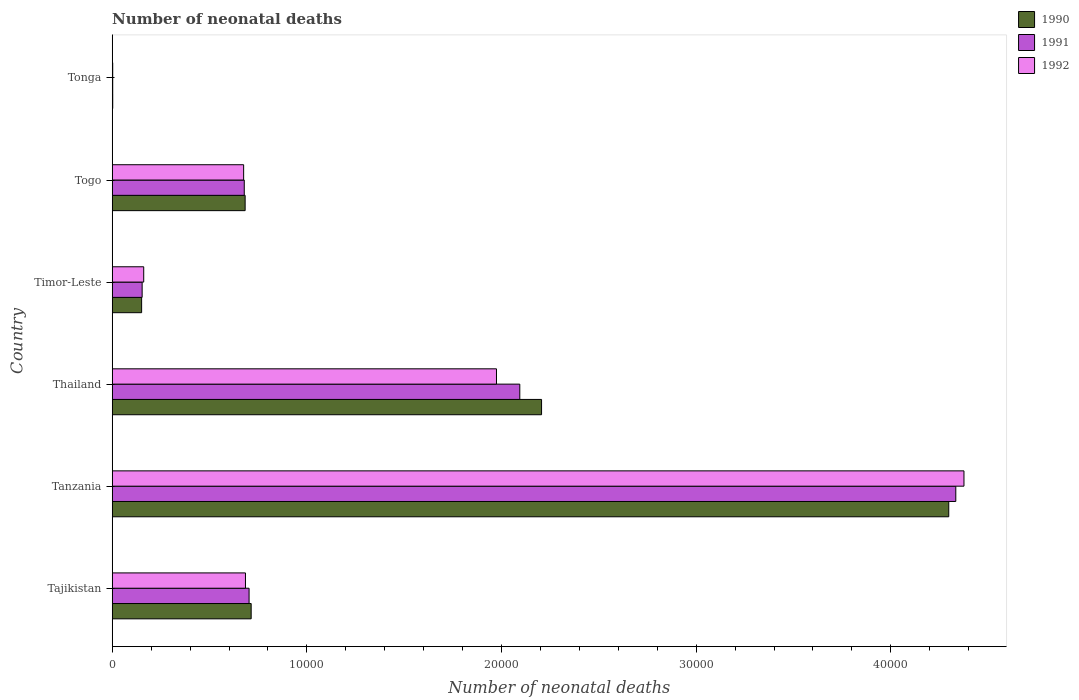Are the number of bars per tick equal to the number of legend labels?
Provide a succinct answer. Yes. Are the number of bars on each tick of the Y-axis equal?
Make the answer very short. Yes. How many bars are there on the 5th tick from the bottom?
Give a very brief answer. 3. What is the label of the 3rd group of bars from the top?
Give a very brief answer. Timor-Leste. What is the number of neonatal deaths in in 1991 in Tajikistan?
Your answer should be very brief. 7031. Across all countries, what is the maximum number of neonatal deaths in in 1992?
Offer a very short reply. 4.38e+04. Across all countries, what is the minimum number of neonatal deaths in in 1992?
Ensure brevity in your answer.  25. In which country was the number of neonatal deaths in in 1992 maximum?
Give a very brief answer. Tanzania. In which country was the number of neonatal deaths in in 1990 minimum?
Keep it short and to the point. Tonga. What is the total number of neonatal deaths in in 1992 in the graph?
Your answer should be compact. 7.87e+04. What is the difference between the number of neonatal deaths in in 1991 in Tanzania and that in Timor-Leste?
Provide a short and direct response. 4.18e+04. What is the difference between the number of neonatal deaths in in 1992 in Tonga and the number of neonatal deaths in in 1990 in Togo?
Your answer should be compact. -6803. What is the average number of neonatal deaths in in 1990 per country?
Offer a terse response. 1.34e+04. What is the difference between the number of neonatal deaths in in 1990 and number of neonatal deaths in in 1991 in Tanzania?
Offer a very short reply. -362. In how many countries, is the number of neonatal deaths in in 1990 greater than 38000 ?
Keep it short and to the point. 1. What is the ratio of the number of neonatal deaths in in 1990 in Tanzania to that in Togo?
Ensure brevity in your answer.  6.29. Is the number of neonatal deaths in in 1992 in Timor-Leste less than that in Togo?
Your response must be concise. Yes. Is the difference between the number of neonatal deaths in in 1990 in Tanzania and Tonga greater than the difference between the number of neonatal deaths in in 1991 in Tanzania and Tonga?
Provide a short and direct response. No. What is the difference between the highest and the second highest number of neonatal deaths in in 1992?
Your answer should be compact. 2.40e+04. What is the difference between the highest and the lowest number of neonatal deaths in in 1992?
Provide a succinct answer. 4.37e+04. In how many countries, is the number of neonatal deaths in in 1992 greater than the average number of neonatal deaths in in 1992 taken over all countries?
Offer a very short reply. 2. Is the sum of the number of neonatal deaths in in 1990 in Tajikistan and Tanzania greater than the maximum number of neonatal deaths in in 1992 across all countries?
Provide a short and direct response. Yes. What does the 2nd bar from the top in Tajikistan represents?
Ensure brevity in your answer.  1991. Is it the case that in every country, the sum of the number of neonatal deaths in in 1992 and number of neonatal deaths in in 1990 is greater than the number of neonatal deaths in in 1991?
Make the answer very short. Yes. How many bars are there?
Ensure brevity in your answer.  18. What is the difference between two consecutive major ticks on the X-axis?
Your answer should be very brief. 10000. Are the values on the major ticks of X-axis written in scientific E-notation?
Keep it short and to the point. No. Does the graph contain any zero values?
Offer a very short reply. No. Where does the legend appear in the graph?
Offer a very short reply. Top right. How are the legend labels stacked?
Provide a succinct answer. Vertical. What is the title of the graph?
Offer a terse response. Number of neonatal deaths. What is the label or title of the X-axis?
Ensure brevity in your answer.  Number of neonatal deaths. What is the Number of neonatal deaths in 1990 in Tajikistan?
Your answer should be very brief. 7138. What is the Number of neonatal deaths of 1991 in Tajikistan?
Your answer should be compact. 7031. What is the Number of neonatal deaths in 1992 in Tajikistan?
Offer a very short reply. 6845. What is the Number of neonatal deaths in 1990 in Tanzania?
Give a very brief answer. 4.30e+04. What is the Number of neonatal deaths in 1991 in Tanzania?
Provide a short and direct response. 4.33e+04. What is the Number of neonatal deaths in 1992 in Tanzania?
Keep it short and to the point. 4.38e+04. What is the Number of neonatal deaths in 1990 in Thailand?
Ensure brevity in your answer.  2.21e+04. What is the Number of neonatal deaths in 1991 in Thailand?
Make the answer very short. 2.09e+04. What is the Number of neonatal deaths in 1992 in Thailand?
Make the answer very short. 1.97e+04. What is the Number of neonatal deaths of 1990 in Timor-Leste?
Give a very brief answer. 1510. What is the Number of neonatal deaths in 1991 in Timor-Leste?
Keep it short and to the point. 1537. What is the Number of neonatal deaths of 1992 in Timor-Leste?
Provide a succinct answer. 1618. What is the Number of neonatal deaths of 1990 in Togo?
Offer a very short reply. 6828. What is the Number of neonatal deaths in 1991 in Togo?
Your answer should be very brief. 6783. What is the Number of neonatal deaths of 1992 in Togo?
Give a very brief answer. 6751. What is the Number of neonatal deaths in 1991 in Tonga?
Provide a short and direct response. 25. Across all countries, what is the maximum Number of neonatal deaths of 1990?
Your answer should be very brief. 4.30e+04. Across all countries, what is the maximum Number of neonatal deaths in 1991?
Make the answer very short. 4.33e+04. Across all countries, what is the maximum Number of neonatal deaths of 1992?
Offer a terse response. 4.38e+04. Across all countries, what is the minimum Number of neonatal deaths in 1990?
Provide a short and direct response. 26. Across all countries, what is the minimum Number of neonatal deaths of 1991?
Ensure brevity in your answer.  25. Across all countries, what is the minimum Number of neonatal deaths in 1992?
Your answer should be compact. 25. What is the total Number of neonatal deaths of 1990 in the graph?
Your answer should be very brief. 8.05e+04. What is the total Number of neonatal deaths in 1991 in the graph?
Offer a very short reply. 7.97e+04. What is the total Number of neonatal deaths of 1992 in the graph?
Provide a short and direct response. 7.87e+04. What is the difference between the Number of neonatal deaths of 1990 in Tajikistan and that in Tanzania?
Provide a short and direct response. -3.58e+04. What is the difference between the Number of neonatal deaths in 1991 in Tajikistan and that in Tanzania?
Provide a succinct answer. -3.63e+04. What is the difference between the Number of neonatal deaths of 1992 in Tajikistan and that in Tanzania?
Offer a terse response. -3.69e+04. What is the difference between the Number of neonatal deaths in 1990 in Tajikistan and that in Thailand?
Your answer should be very brief. -1.49e+04. What is the difference between the Number of neonatal deaths of 1991 in Tajikistan and that in Thailand?
Your answer should be compact. -1.39e+04. What is the difference between the Number of neonatal deaths of 1992 in Tajikistan and that in Thailand?
Keep it short and to the point. -1.29e+04. What is the difference between the Number of neonatal deaths in 1990 in Tajikistan and that in Timor-Leste?
Your answer should be compact. 5628. What is the difference between the Number of neonatal deaths in 1991 in Tajikistan and that in Timor-Leste?
Give a very brief answer. 5494. What is the difference between the Number of neonatal deaths in 1992 in Tajikistan and that in Timor-Leste?
Give a very brief answer. 5227. What is the difference between the Number of neonatal deaths in 1990 in Tajikistan and that in Togo?
Provide a short and direct response. 310. What is the difference between the Number of neonatal deaths in 1991 in Tajikistan and that in Togo?
Your response must be concise. 248. What is the difference between the Number of neonatal deaths of 1992 in Tajikistan and that in Togo?
Give a very brief answer. 94. What is the difference between the Number of neonatal deaths of 1990 in Tajikistan and that in Tonga?
Provide a short and direct response. 7112. What is the difference between the Number of neonatal deaths of 1991 in Tajikistan and that in Tonga?
Offer a terse response. 7006. What is the difference between the Number of neonatal deaths of 1992 in Tajikistan and that in Tonga?
Give a very brief answer. 6820. What is the difference between the Number of neonatal deaths in 1990 in Tanzania and that in Thailand?
Keep it short and to the point. 2.09e+04. What is the difference between the Number of neonatal deaths in 1991 in Tanzania and that in Thailand?
Your response must be concise. 2.24e+04. What is the difference between the Number of neonatal deaths in 1992 in Tanzania and that in Thailand?
Provide a succinct answer. 2.40e+04. What is the difference between the Number of neonatal deaths in 1990 in Tanzania and that in Timor-Leste?
Provide a succinct answer. 4.15e+04. What is the difference between the Number of neonatal deaths in 1991 in Tanzania and that in Timor-Leste?
Your response must be concise. 4.18e+04. What is the difference between the Number of neonatal deaths in 1992 in Tanzania and that in Timor-Leste?
Ensure brevity in your answer.  4.21e+04. What is the difference between the Number of neonatal deaths of 1990 in Tanzania and that in Togo?
Your answer should be very brief. 3.61e+04. What is the difference between the Number of neonatal deaths of 1991 in Tanzania and that in Togo?
Ensure brevity in your answer.  3.66e+04. What is the difference between the Number of neonatal deaths of 1992 in Tanzania and that in Togo?
Keep it short and to the point. 3.70e+04. What is the difference between the Number of neonatal deaths of 1990 in Tanzania and that in Tonga?
Your answer should be compact. 4.30e+04. What is the difference between the Number of neonatal deaths of 1991 in Tanzania and that in Tonga?
Keep it short and to the point. 4.33e+04. What is the difference between the Number of neonatal deaths in 1992 in Tanzania and that in Tonga?
Offer a very short reply. 4.37e+04. What is the difference between the Number of neonatal deaths of 1990 in Thailand and that in Timor-Leste?
Make the answer very short. 2.05e+04. What is the difference between the Number of neonatal deaths in 1991 in Thailand and that in Timor-Leste?
Provide a short and direct response. 1.94e+04. What is the difference between the Number of neonatal deaths in 1992 in Thailand and that in Timor-Leste?
Your response must be concise. 1.81e+04. What is the difference between the Number of neonatal deaths in 1990 in Thailand and that in Togo?
Give a very brief answer. 1.52e+04. What is the difference between the Number of neonatal deaths in 1991 in Thailand and that in Togo?
Make the answer very short. 1.42e+04. What is the difference between the Number of neonatal deaths of 1992 in Thailand and that in Togo?
Your answer should be very brief. 1.30e+04. What is the difference between the Number of neonatal deaths in 1990 in Thailand and that in Tonga?
Make the answer very short. 2.20e+04. What is the difference between the Number of neonatal deaths of 1991 in Thailand and that in Tonga?
Give a very brief answer. 2.09e+04. What is the difference between the Number of neonatal deaths of 1992 in Thailand and that in Tonga?
Make the answer very short. 1.97e+04. What is the difference between the Number of neonatal deaths in 1990 in Timor-Leste and that in Togo?
Give a very brief answer. -5318. What is the difference between the Number of neonatal deaths of 1991 in Timor-Leste and that in Togo?
Offer a terse response. -5246. What is the difference between the Number of neonatal deaths of 1992 in Timor-Leste and that in Togo?
Provide a succinct answer. -5133. What is the difference between the Number of neonatal deaths in 1990 in Timor-Leste and that in Tonga?
Provide a succinct answer. 1484. What is the difference between the Number of neonatal deaths in 1991 in Timor-Leste and that in Tonga?
Offer a very short reply. 1512. What is the difference between the Number of neonatal deaths in 1992 in Timor-Leste and that in Tonga?
Offer a very short reply. 1593. What is the difference between the Number of neonatal deaths of 1990 in Togo and that in Tonga?
Your answer should be compact. 6802. What is the difference between the Number of neonatal deaths in 1991 in Togo and that in Tonga?
Your response must be concise. 6758. What is the difference between the Number of neonatal deaths of 1992 in Togo and that in Tonga?
Your answer should be compact. 6726. What is the difference between the Number of neonatal deaths in 1990 in Tajikistan and the Number of neonatal deaths in 1991 in Tanzania?
Your response must be concise. -3.62e+04. What is the difference between the Number of neonatal deaths of 1990 in Tajikistan and the Number of neonatal deaths of 1992 in Tanzania?
Offer a very short reply. -3.66e+04. What is the difference between the Number of neonatal deaths in 1991 in Tajikistan and the Number of neonatal deaths in 1992 in Tanzania?
Ensure brevity in your answer.  -3.67e+04. What is the difference between the Number of neonatal deaths in 1990 in Tajikistan and the Number of neonatal deaths in 1991 in Thailand?
Provide a succinct answer. -1.38e+04. What is the difference between the Number of neonatal deaths of 1990 in Tajikistan and the Number of neonatal deaths of 1992 in Thailand?
Ensure brevity in your answer.  -1.26e+04. What is the difference between the Number of neonatal deaths in 1991 in Tajikistan and the Number of neonatal deaths in 1992 in Thailand?
Offer a very short reply. -1.27e+04. What is the difference between the Number of neonatal deaths in 1990 in Tajikistan and the Number of neonatal deaths in 1991 in Timor-Leste?
Provide a short and direct response. 5601. What is the difference between the Number of neonatal deaths in 1990 in Tajikistan and the Number of neonatal deaths in 1992 in Timor-Leste?
Offer a terse response. 5520. What is the difference between the Number of neonatal deaths of 1991 in Tajikistan and the Number of neonatal deaths of 1992 in Timor-Leste?
Your answer should be very brief. 5413. What is the difference between the Number of neonatal deaths of 1990 in Tajikistan and the Number of neonatal deaths of 1991 in Togo?
Make the answer very short. 355. What is the difference between the Number of neonatal deaths of 1990 in Tajikistan and the Number of neonatal deaths of 1992 in Togo?
Ensure brevity in your answer.  387. What is the difference between the Number of neonatal deaths of 1991 in Tajikistan and the Number of neonatal deaths of 1992 in Togo?
Your answer should be very brief. 280. What is the difference between the Number of neonatal deaths in 1990 in Tajikistan and the Number of neonatal deaths in 1991 in Tonga?
Your answer should be very brief. 7113. What is the difference between the Number of neonatal deaths of 1990 in Tajikistan and the Number of neonatal deaths of 1992 in Tonga?
Offer a very short reply. 7113. What is the difference between the Number of neonatal deaths in 1991 in Tajikistan and the Number of neonatal deaths in 1992 in Tonga?
Give a very brief answer. 7006. What is the difference between the Number of neonatal deaths of 1990 in Tanzania and the Number of neonatal deaths of 1991 in Thailand?
Your answer should be compact. 2.20e+04. What is the difference between the Number of neonatal deaths in 1990 in Tanzania and the Number of neonatal deaths in 1992 in Thailand?
Your answer should be very brief. 2.32e+04. What is the difference between the Number of neonatal deaths of 1991 in Tanzania and the Number of neonatal deaths of 1992 in Thailand?
Ensure brevity in your answer.  2.36e+04. What is the difference between the Number of neonatal deaths in 1990 in Tanzania and the Number of neonatal deaths in 1991 in Timor-Leste?
Keep it short and to the point. 4.14e+04. What is the difference between the Number of neonatal deaths in 1990 in Tanzania and the Number of neonatal deaths in 1992 in Timor-Leste?
Keep it short and to the point. 4.14e+04. What is the difference between the Number of neonatal deaths in 1991 in Tanzania and the Number of neonatal deaths in 1992 in Timor-Leste?
Keep it short and to the point. 4.17e+04. What is the difference between the Number of neonatal deaths in 1990 in Tanzania and the Number of neonatal deaths in 1991 in Togo?
Keep it short and to the point. 3.62e+04. What is the difference between the Number of neonatal deaths in 1990 in Tanzania and the Number of neonatal deaths in 1992 in Togo?
Offer a terse response. 3.62e+04. What is the difference between the Number of neonatal deaths of 1991 in Tanzania and the Number of neonatal deaths of 1992 in Togo?
Give a very brief answer. 3.66e+04. What is the difference between the Number of neonatal deaths of 1990 in Tanzania and the Number of neonatal deaths of 1991 in Tonga?
Offer a very short reply. 4.30e+04. What is the difference between the Number of neonatal deaths of 1990 in Tanzania and the Number of neonatal deaths of 1992 in Tonga?
Provide a succinct answer. 4.30e+04. What is the difference between the Number of neonatal deaths in 1991 in Tanzania and the Number of neonatal deaths in 1992 in Tonga?
Offer a very short reply. 4.33e+04. What is the difference between the Number of neonatal deaths in 1990 in Thailand and the Number of neonatal deaths in 1991 in Timor-Leste?
Offer a terse response. 2.05e+04. What is the difference between the Number of neonatal deaths of 1990 in Thailand and the Number of neonatal deaths of 1992 in Timor-Leste?
Give a very brief answer. 2.04e+04. What is the difference between the Number of neonatal deaths in 1991 in Thailand and the Number of neonatal deaths in 1992 in Timor-Leste?
Make the answer very short. 1.93e+04. What is the difference between the Number of neonatal deaths in 1990 in Thailand and the Number of neonatal deaths in 1991 in Togo?
Provide a succinct answer. 1.53e+04. What is the difference between the Number of neonatal deaths in 1990 in Thailand and the Number of neonatal deaths in 1992 in Togo?
Give a very brief answer. 1.53e+04. What is the difference between the Number of neonatal deaths of 1991 in Thailand and the Number of neonatal deaths of 1992 in Togo?
Provide a short and direct response. 1.42e+04. What is the difference between the Number of neonatal deaths of 1990 in Thailand and the Number of neonatal deaths of 1991 in Tonga?
Make the answer very short. 2.20e+04. What is the difference between the Number of neonatal deaths of 1990 in Thailand and the Number of neonatal deaths of 1992 in Tonga?
Your answer should be compact. 2.20e+04. What is the difference between the Number of neonatal deaths of 1991 in Thailand and the Number of neonatal deaths of 1992 in Tonga?
Provide a succinct answer. 2.09e+04. What is the difference between the Number of neonatal deaths in 1990 in Timor-Leste and the Number of neonatal deaths in 1991 in Togo?
Provide a short and direct response. -5273. What is the difference between the Number of neonatal deaths of 1990 in Timor-Leste and the Number of neonatal deaths of 1992 in Togo?
Offer a terse response. -5241. What is the difference between the Number of neonatal deaths of 1991 in Timor-Leste and the Number of neonatal deaths of 1992 in Togo?
Give a very brief answer. -5214. What is the difference between the Number of neonatal deaths of 1990 in Timor-Leste and the Number of neonatal deaths of 1991 in Tonga?
Ensure brevity in your answer.  1485. What is the difference between the Number of neonatal deaths in 1990 in Timor-Leste and the Number of neonatal deaths in 1992 in Tonga?
Make the answer very short. 1485. What is the difference between the Number of neonatal deaths in 1991 in Timor-Leste and the Number of neonatal deaths in 1992 in Tonga?
Make the answer very short. 1512. What is the difference between the Number of neonatal deaths in 1990 in Togo and the Number of neonatal deaths in 1991 in Tonga?
Your response must be concise. 6803. What is the difference between the Number of neonatal deaths in 1990 in Togo and the Number of neonatal deaths in 1992 in Tonga?
Give a very brief answer. 6803. What is the difference between the Number of neonatal deaths of 1991 in Togo and the Number of neonatal deaths of 1992 in Tonga?
Keep it short and to the point. 6758. What is the average Number of neonatal deaths in 1990 per country?
Make the answer very short. 1.34e+04. What is the average Number of neonatal deaths in 1991 per country?
Provide a short and direct response. 1.33e+04. What is the average Number of neonatal deaths of 1992 per country?
Offer a very short reply. 1.31e+04. What is the difference between the Number of neonatal deaths of 1990 and Number of neonatal deaths of 1991 in Tajikistan?
Your response must be concise. 107. What is the difference between the Number of neonatal deaths of 1990 and Number of neonatal deaths of 1992 in Tajikistan?
Make the answer very short. 293. What is the difference between the Number of neonatal deaths in 1991 and Number of neonatal deaths in 1992 in Tajikistan?
Your answer should be very brief. 186. What is the difference between the Number of neonatal deaths of 1990 and Number of neonatal deaths of 1991 in Tanzania?
Keep it short and to the point. -362. What is the difference between the Number of neonatal deaths of 1990 and Number of neonatal deaths of 1992 in Tanzania?
Give a very brief answer. -782. What is the difference between the Number of neonatal deaths in 1991 and Number of neonatal deaths in 1992 in Tanzania?
Provide a short and direct response. -420. What is the difference between the Number of neonatal deaths in 1990 and Number of neonatal deaths in 1991 in Thailand?
Your answer should be compact. 1118. What is the difference between the Number of neonatal deaths in 1990 and Number of neonatal deaths in 1992 in Thailand?
Your response must be concise. 2316. What is the difference between the Number of neonatal deaths in 1991 and Number of neonatal deaths in 1992 in Thailand?
Your answer should be compact. 1198. What is the difference between the Number of neonatal deaths of 1990 and Number of neonatal deaths of 1992 in Timor-Leste?
Provide a succinct answer. -108. What is the difference between the Number of neonatal deaths of 1991 and Number of neonatal deaths of 1992 in Timor-Leste?
Offer a very short reply. -81. What is the difference between the Number of neonatal deaths in 1990 and Number of neonatal deaths in 1991 in Togo?
Your answer should be very brief. 45. What is the difference between the Number of neonatal deaths of 1990 and Number of neonatal deaths of 1992 in Togo?
Keep it short and to the point. 77. What is the difference between the Number of neonatal deaths in 1990 and Number of neonatal deaths in 1991 in Tonga?
Give a very brief answer. 1. What is the ratio of the Number of neonatal deaths in 1990 in Tajikistan to that in Tanzania?
Offer a terse response. 0.17. What is the ratio of the Number of neonatal deaths of 1991 in Tajikistan to that in Tanzania?
Give a very brief answer. 0.16. What is the ratio of the Number of neonatal deaths in 1992 in Tajikistan to that in Tanzania?
Provide a short and direct response. 0.16. What is the ratio of the Number of neonatal deaths of 1990 in Tajikistan to that in Thailand?
Provide a short and direct response. 0.32. What is the ratio of the Number of neonatal deaths in 1991 in Tajikistan to that in Thailand?
Your answer should be compact. 0.34. What is the ratio of the Number of neonatal deaths in 1992 in Tajikistan to that in Thailand?
Provide a succinct answer. 0.35. What is the ratio of the Number of neonatal deaths of 1990 in Tajikistan to that in Timor-Leste?
Give a very brief answer. 4.73. What is the ratio of the Number of neonatal deaths of 1991 in Tajikistan to that in Timor-Leste?
Provide a short and direct response. 4.57. What is the ratio of the Number of neonatal deaths of 1992 in Tajikistan to that in Timor-Leste?
Keep it short and to the point. 4.23. What is the ratio of the Number of neonatal deaths in 1990 in Tajikistan to that in Togo?
Your answer should be very brief. 1.05. What is the ratio of the Number of neonatal deaths in 1991 in Tajikistan to that in Togo?
Give a very brief answer. 1.04. What is the ratio of the Number of neonatal deaths of 1992 in Tajikistan to that in Togo?
Your response must be concise. 1.01. What is the ratio of the Number of neonatal deaths in 1990 in Tajikistan to that in Tonga?
Make the answer very short. 274.54. What is the ratio of the Number of neonatal deaths in 1991 in Tajikistan to that in Tonga?
Offer a terse response. 281.24. What is the ratio of the Number of neonatal deaths of 1992 in Tajikistan to that in Tonga?
Your answer should be compact. 273.8. What is the ratio of the Number of neonatal deaths in 1990 in Tanzania to that in Thailand?
Ensure brevity in your answer.  1.95. What is the ratio of the Number of neonatal deaths of 1991 in Tanzania to that in Thailand?
Offer a terse response. 2.07. What is the ratio of the Number of neonatal deaths of 1992 in Tanzania to that in Thailand?
Provide a short and direct response. 2.22. What is the ratio of the Number of neonatal deaths of 1990 in Tanzania to that in Timor-Leste?
Offer a very short reply. 28.46. What is the ratio of the Number of neonatal deaths of 1991 in Tanzania to that in Timor-Leste?
Your answer should be very brief. 28.2. What is the ratio of the Number of neonatal deaths of 1992 in Tanzania to that in Timor-Leste?
Keep it short and to the point. 27.04. What is the ratio of the Number of neonatal deaths in 1990 in Tanzania to that in Togo?
Provide a short and direct response. 6.29. What is the ratio of the Number of neonatal deaths of 1991 in Tanzania to that in Togo?
Keep it short and to the point. 6.39. What is the ratio of the Number of neonatal deaths in 1992 in Tanzania to that in Togo?
Give a very brief answer. 6.48. What is the ratio of the Number of neonatal deaths in 1990 in Tanzania to that in Tonga?
Provide a succinct answer. 1652.92. What is the ratio of the Number of neonatal deaths in 1991 in Tanzania to that in Tonga?
Provide a succinct answer. 1733.52. What is the ratio of the Number of neonatal deaths in 1992 in Tanzania to that in Tonga?
Provide a succinct answer. 1750.32. What is the ratio of the Number of neonatal deaths in 1990 in Thailand to that in Timor-Leste?
Offer a terse response. 14.61. What is the ratio of the Number of neonatal deaths of 1991 in Thailand to that in Timor-Leste?
Make the answer very short. 13.62. What is the ratio of the Number of neonatal deaths in 1992 in Thailand to that in Timor-Leste?
Ensure brevity in your answer.  12.2. What is the ratio of the Number of neonatal deaths of 1990 in Thailand to that in Togo?
Provide a succinct answer. 3.23. What is the ratio of the Number of neonatal deaths of 1991 in Thailand to that in Togo?
Provide a succinct answer. 3.09. What is the ratio of the Number of neonatal deaths of 1992 in Thailand to that in Togo?
Your answer should be very brief. 2.92. What is the ratio of the Number of neonatal deaths of 1990 in Thailand to that in Tonga?
Give a very brief answer. 848.35. What is the ratio of the Number of neonatal deaths in 1991 in Thailand to that in Tonga?
Your answer should be compact. 837.56. What is the ratio of the Number of neonatal deaths of 1992 in Thailand to that in Tonga?
Your response must be concise. 789.64. What is the ratio of the Number of neonatal deaths in 1990 in Timor-Leste to that in Togo?
Give a very brief answer. 0.22. What is the ratio of the Number of neonatal deaths in 1991 in Timor-Leste to that in Togo?
Make the answer very short. 0.23. What is the ratio of the Number of neonatal deaths of 1992 in Timor-Leste to that in Togo?
Provide a short and direct response. 0.24. What is the ratio of the Number of neonatal deaths of 1990 in Timor-Leste to that in Tonga?
Keep it short and to the point. 58.08. What is the ratio of the Number of neonatal deaths of 1991 in Timor-Leste to that in Tonga?
Keep it short and to the point. 61.48. What is the ratio of the Number of neonatal deaths in 1992 in Timor-Leste to that in Tonga?
Keep it short and to the point. 64.72. What is the ratio of the Number of neonatal deaths of 1990 in Togo to that in Tonga?
Ensure brevity in your answer.  262.62. What is the ratio of the Number of neonatal deaths in 1991 in Togo to that in Tonga?
Provide a short and direct response. 271.32. What is the ratio of the Number of neonatal deaths of 1992 in Togo to that in Tonga?
Ensure brevity in your answer.  270.04. What is the difference between the highest and the second highest Number of neonatal deaths in 1990?
Offer a terse response. 2.09e+04. What is the difference between the highest and the second highest Number of neonatal deaths of 1991?
Make the answer very short. 2.24e+04. What is the difference between the highest and the second highest Number of neonatal deaths in 1992?
Keep it short and to the point. 2.40e+04. What is the difference between the highest and the lowest Number of neonatal deaths of 1990?
Provide a succinct answer. 4.30e+04. What is the difference between the highest and the lowest Number of neonatal deaths of 1991?
Your answer should be very brief. 4.33e+04. What is the difference between the highest and the lowest Number of neonatal deaths in 1992?
Give a very brief answer. 4.37e+04. 